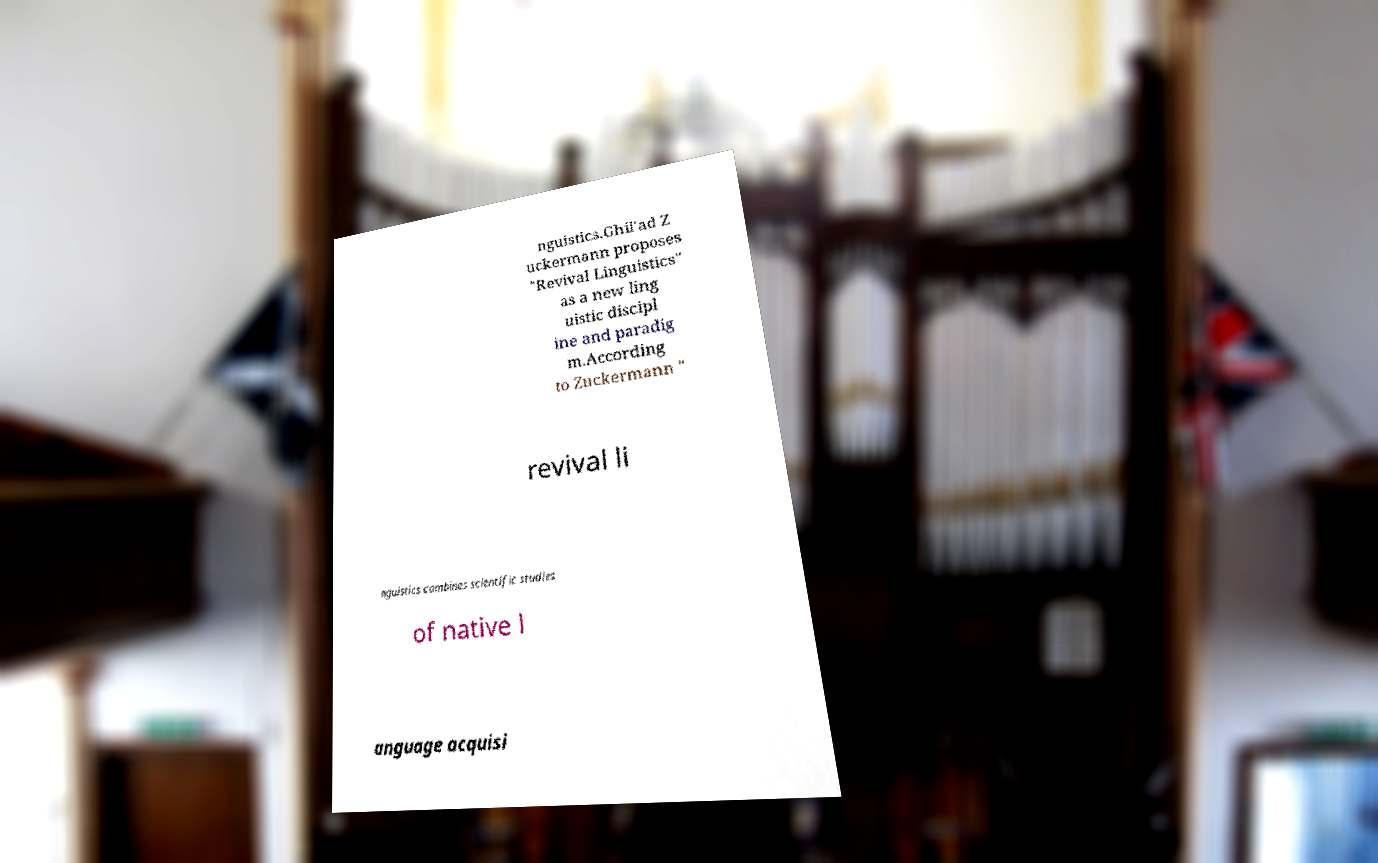For documentation purposes, I need the text within this image transcribed. Could you provide that? nguistics.Ghil'ad Z uckermann proposes "Revival Linguistics" as a new ling uistic discipl ine and paradig m.According to Zuckermann " revival li nguistics combines scientific studies of native l anguage acquisi 